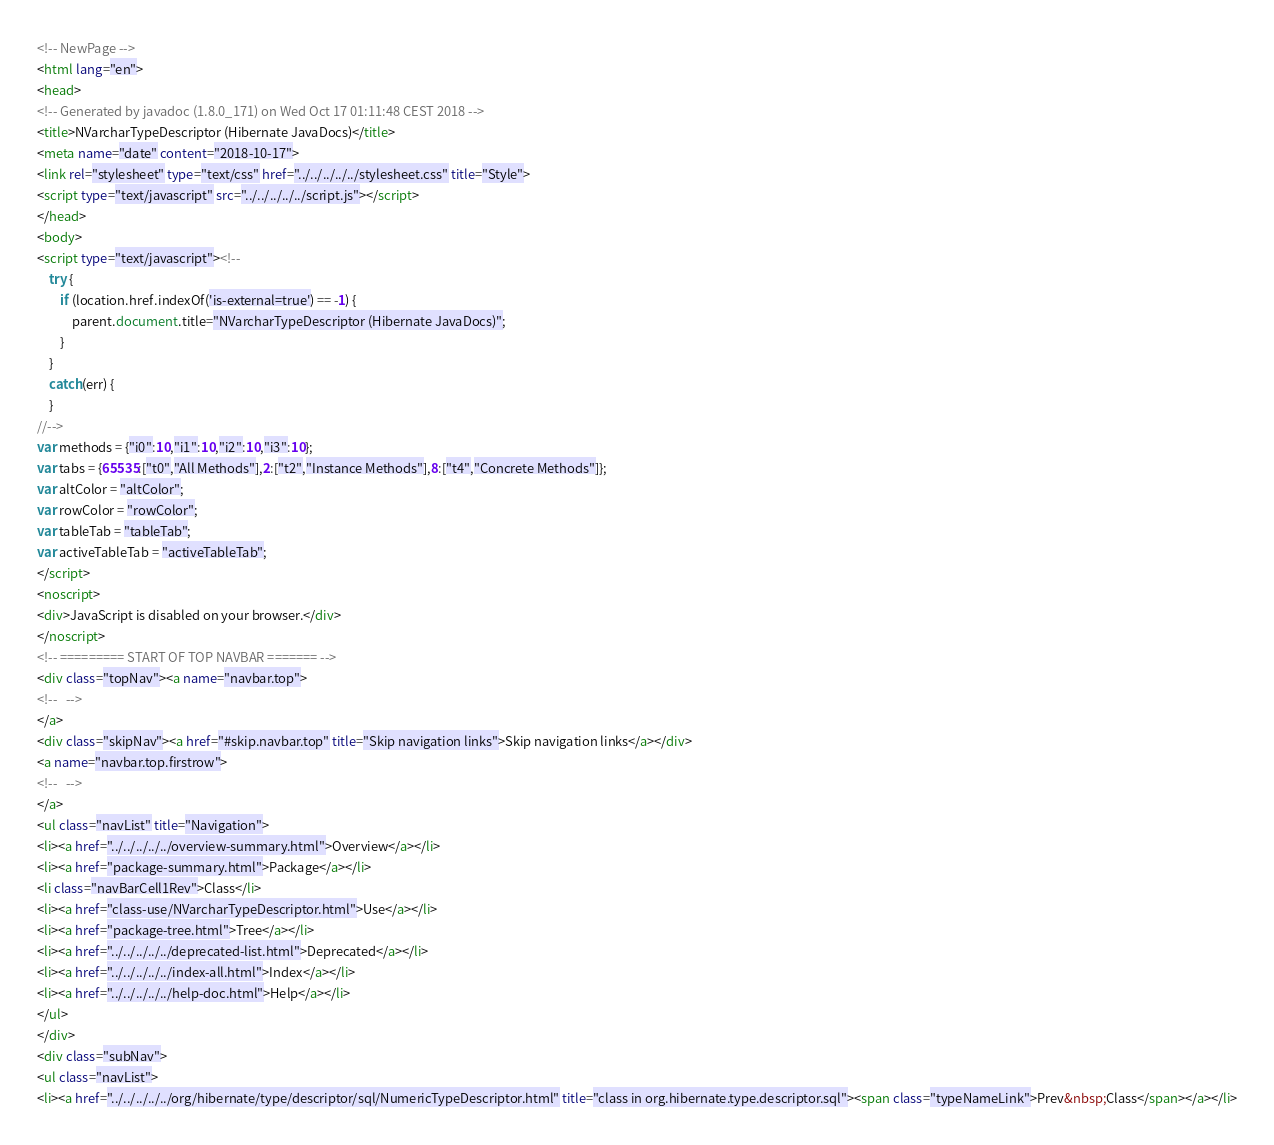<code> <loc_0><loc_0><loc_500><loc_500><_HTML_><!-- NewPage -->
<html lang="en">
<head>
<!-- Generated by javadoc (1.8.0_171) on Wed Oct 17 01:11:48 CEST 2018 -->
<title>NVarcharTypeDescriptor (Hibernate JavaDocs)</title>
<meta name="date" content="2018-10-17">
<link rel="stylesheet" type="text/css" href="../../../../../stylesheet.css" title="Style">
<script type="text/javascript" src="../../../../../script.js"></script>
</head>
<body>
<script type="text/javascript"><!--
    try {
        if (location.href.indexOf('is-external=true') == -1) {
            parent.document.title="NVarcharTypeDescriptor (Hibernate JavaDocs)";
        }
    }
    catch(err) {
    }
//-->
var methods = {"i0":10,"i1":10,"i2":10,"i3":10};
var tabs = {65535:["t0","All Methods"],2:["t2","Instance Methods"],8:["t4","Concrete Methods"]};
var altColor = "altColor";
var rowColor = "rowColor";
var tableTab = "tableTab";
var activeTableTab = "activeTableTab";
</script>
<noscript>
<div>JavaScript is disabled on your browser.</div>
</noscript>
<!-- ========= START OF TOP NAVBAR ======= -->
<div class="topNav"><a name="navbar.top">
<!--   -->
</a>
<div class="skipNav"><a href="#skip.navbar.top" title="Skip navigation links">Skip navigation links</a></div>
<a name="navbar.top.firstrow">
<!--   -->
</a>
<ul class="navList" title="Navigation">
<li><a href="../../../../../overview-summary.html">Overview</a></li>
<li><a href="package-summary.html">Package</a></li>
<li class="navBarCell1Rev">Class</li>
<li><a href="class-use/NVarcharTypeDescriptor.html">Use</a></li>
<li><a href="package-tree.html">Tree</a></li>
<li><a href="../../../../../deprecated-list.html">Deprecated</a></li>
<li><a href="../../../../../index-all.html">Index</a></li>
<li><a href="../../../../../help-doc.html">Help</a></li>
</ul>
</div>
<div class="subNav">
<ul class="navList">
<li><a href="../../../../../org/hibernate/type/descriptor/sql/NumericTypeDescriptor.html" title="class in org.hibernate.type.descriptor.sql"><span class="typeNameLink">Prev&nbsp;Class</span></a></li></code> 